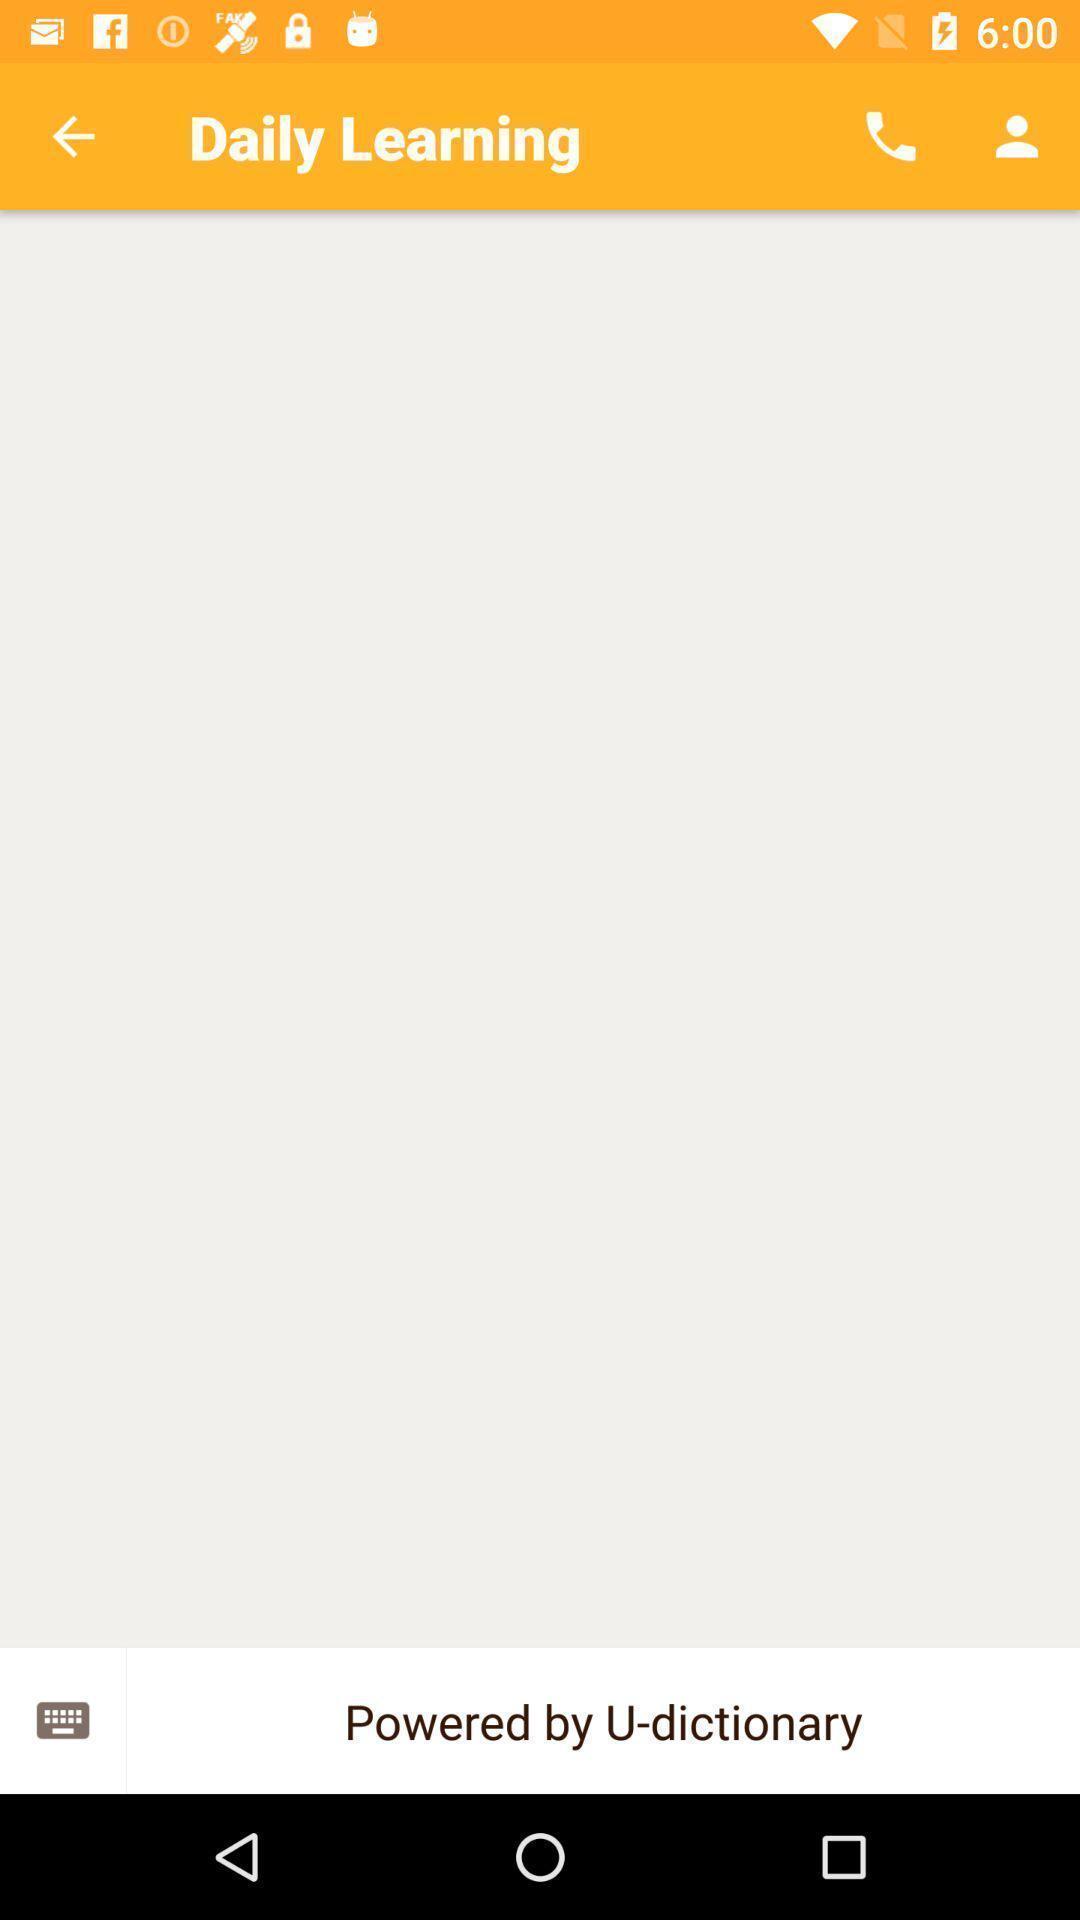What is the overall content of this screenshot? Screen shows daily learning page in calling app. 